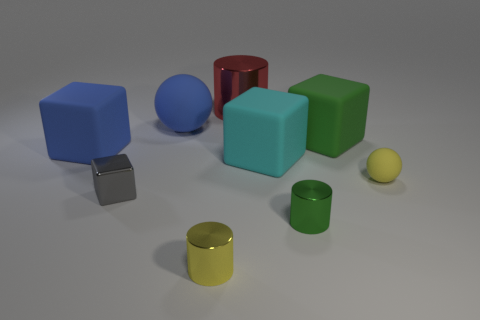Subtract all red cubes. Subtract all blue cylinders. How many cubes are left? 4 Add 1 large blue things. How many objects exist? 10 Subtract all cubes. How many objects are left? 5 Add 6 matte spheres. How many matte spheres exist? 8 Subtract 0 cyan balls. How many objects are left? 9 Subtract all large metallic cylinders. Subtract all small blue metallic cylinders. How many objects are left? 8 Add 4 big red things. How many big red things are left? 5 